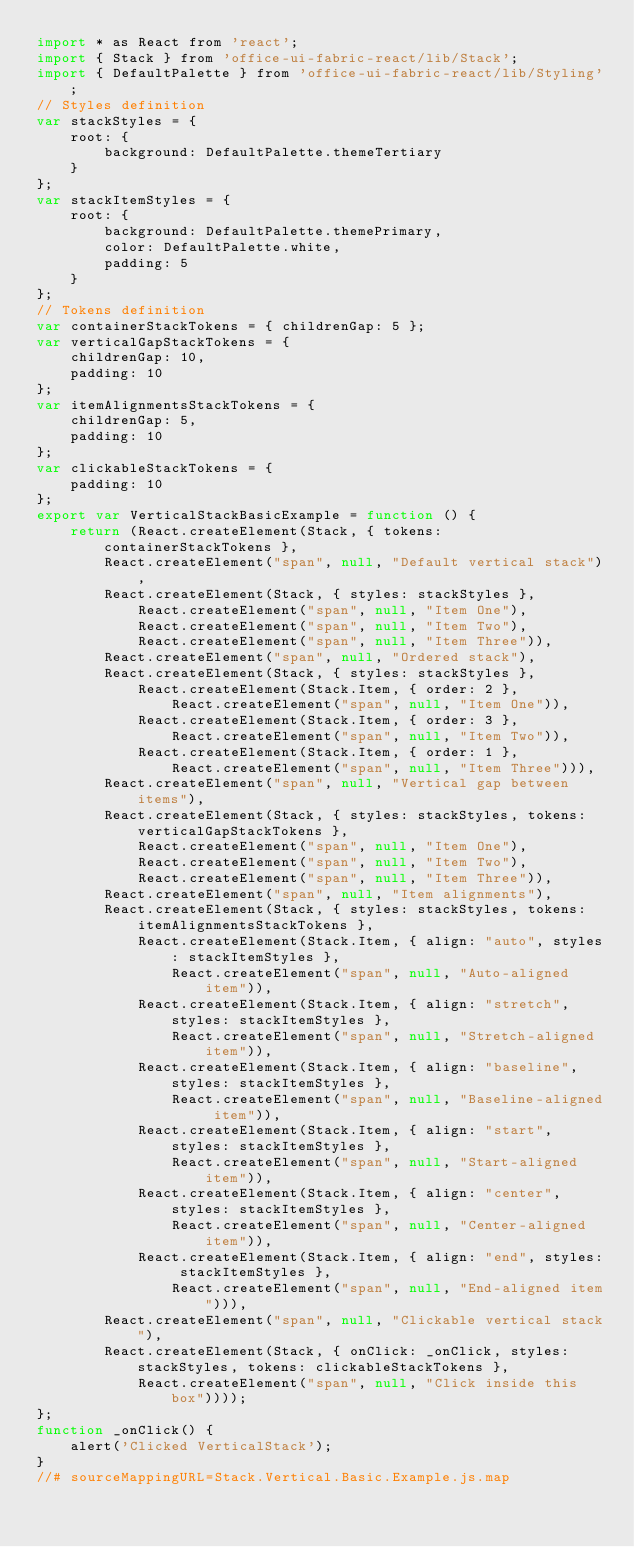<code> <loc_0><loc_0><loc_500><loc_500><_JavaScript_>import * as React from 'react';
import { Stack } from 'office-ui-fabric-react/lib/Stack';
import { DefaultPalette } from 'office-ui-fabric-react/lib/Styling';
// Styles definition
var stackStyles = {
    root: {
        background: DefaultPalette.themeTertiary
    }
};
var stackItemStyles = {
    root: {
        background: DefaultPalette.themePrimary,
        color: DefaultPalette.white,
        padding: 5
    }
};
// Tokens definition
var containerStackTokens = { childrenGap: 5 };
var verticalGapStackTokens = {
    childrenGap: 10,
    padding: 10
};
var itemAlignmentsStackTokens = {
    childrenGap: 5,
    padding: 10
};
var clickableStackTokens = {
    padding: 10
};
export var VerticalStackBasicExample = function () {
    return (React.createElement(Stack, { tokens: containerStackTokens },
        React.createElement("span", null, "Default vertical stack"),
        React.createElement(Stack, { styles: stackStyles },
            React.createElement("span", null, "Item One"),
            React.createElement("span", null, "Item Two"),
            React.createElement("span", null, "Item Three")),
        React.createElement("span", null, "Ordered stack"),
        React.createElement(Stack, { styles: stackStyles },
            React.createElement(Stack.Item, { order: 2 },
                React.createElement("span", null, "Item One")),
            React.createElement(Stack.Item, { order: 3 },
                React.createElement("span", null, "Item Two")),
            React.createElement(Stack.Item, { order: 1 },
                React.createElement("span", null, "Item Three"))),
        React.createElement("span", null, "Vertical gap between items"),
        React.createElement(Stack, { styles: stackStyles, tokens: verticalGapStackTokens },
            React.createElement("span", null, "Item One"),
            React.createElement("span", null, "Item Two"),
            React.createElement("span", null, "Item Three")),
        React.createElement("span", null, "Item alignments"),
        React.createElement(Stack, { styles: stackStyles, tokens: itemAlignmentsStackTokens },
            React.createElement(Stack.Item, { align: "auto", styles: stackItemStyles },
                React.createElement("span", null, "Auto-aligned item")),
            React.createElement(Stack.Item, { align: "stretch", styles: stackItemStyles },
                React.createElement("span", null, "Stretch-aligned item")),
            React.createElement(Stack.Item, { align: "baseline", styles: stackItemStyles },
                React.createElement("span", null, "Baseline-aligned item")),
            React.createElement(Stack.Item, { align: "start", styles: stackItemStyles },
                React.createElement("span", null, "Start-aligned item")),
            React.createElement(Stack.Item, { align: "center", styles: stackItemStyles },
                React.createElement("span", null, "Center-aligned item")),
            React.createElement(Stack.Item, { align: "end", styles: stackItemStyles },
                React.createElement("span", null, "End-aligned item"))),
        React.createElement("span", null, "Clickable vertical stack"),
        React.createElement(Stack, { onClick: _onClick, styles: stackStyles, tokens: clickableStackTokens },
            React.createElement("span", null, "Click inside this box"))));
};
function _onClick() {
    alert('Clicked VerticalStack');
}
//# sourceMappingURL=Stack.Vertical.Basic.Example.js.map</code> 